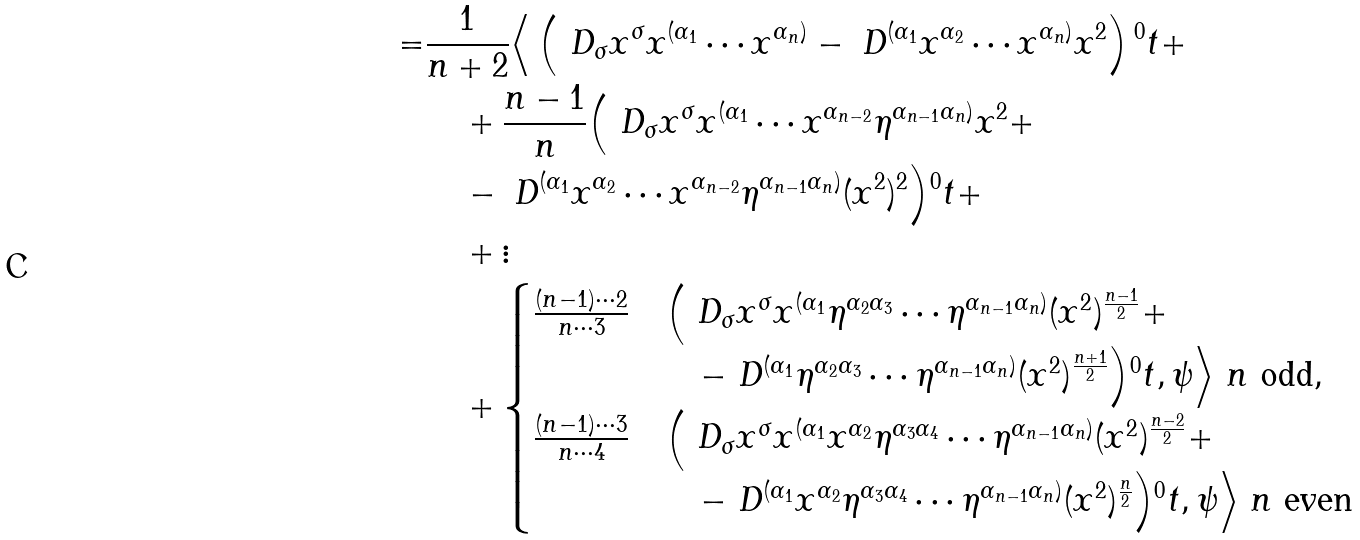<formula> <loc_0><loc_0><loc_500><loc_500>= & \frac { 1 } { n + 2 } \Big \langle \left ( \ D _ { \sigma } x ^ { \sigma } x ^ { ( \alpha _ { 1 } } \cdots x ^ { \alpha _ { n } ) } - \ D ^ { ( \alpha _ { 1 } } x ^ { \alpha _ { 2 } } \cdots x ^ { \alpha _ { n } ) } x ^ { 2 } \right ) { ^ { 0 } t } + \\ & \quad + \frac { n - 1 } { n } \Big ( \ D _ { \sigma } x ^ { \sigma } x ^ { ( \alpha _ { 1 } } \cdots x ^ { \alpha _ { n - 2 } } \eta ^ { \alpha _ { n - 1 } \alpha _ { n } ) } x ^ { 2 } + \\ & \quad - \ D ^ { ( \alpha _ { 1 } } x ^ { \alpha _ { 2 } } \cdots x ^ { \alpha _ { n - 2 } } \eta ^ { \alpha _ { n - 1 } \alpha _ { n } ) } ( x ^ { 2 } ) ^ { 2 } \Big ) { ^ { 0 } t } + \\ & \quad + \vdots \\ & \quad + \begin{cases} \frac { ( n - 1 ) \cdots 2 } { n \cdots 3 } & \Big ( \ D _ { \sigma } x ^ { \sigma } x ^ { ( \alpha _ { 1 } } \eta ^ { \alpha _ { 2 } \alpha _ { 3 } } \cdots \eta ^ { \alpha _ { n - 1 } \alpha _ { n } ) } ( x ^ { 2 } ) ^ { \frac { n - 1 } { 2 } } + \\ & \quad - \ D ^ { ( \alpha _ { 1 } } \eta ^ { \alpha _ { 2 } \alpha _ { 3 } } \cdots \eta ^ { \alpha _ { n - 1 } \alpha _ { n } ) } ( x ^ { 2 } ) ^ { \frac { n + 1 } { 2 } } \Big ) { ^ { 0 } t } , \psi \Big \rangle \ n \text { odd} , \\ \frac { ( n - 1 ) \cdots 3 } { n \cdots 4 } & \Big ( \ D _ { \sigma } x ^ { \sigma } x ^ { ( \alpha _ { 1 } } x ^ { \alpha _ { 2 } } \eta ^ { \alpha _ { 3 } \alpha _ { 4 } } \cdots \eta ^ { \alpha _ { n - 1 } \alpha _ { n } ) } ( x ^ { 2 } ) ^ { \frac { n - 2 } { 2 } } + \\ & \quad - \ D ^ { ( \alpha _ { 1 } } x ^ { \alpha _ { 2 } } \eta ^ { \alpha _ { 3 } \alpha _ { 4 } } \cdots \eta ^ { \alpha _ { n - 1 } \alpha _ { n } ) } ( x ^ { 2 } ) ^ { \frac { n } { 2 } } \Big ) { ^ { 0 } t } , \psi \Big \rangle \ n \text { even} \end{cases}</formula> 